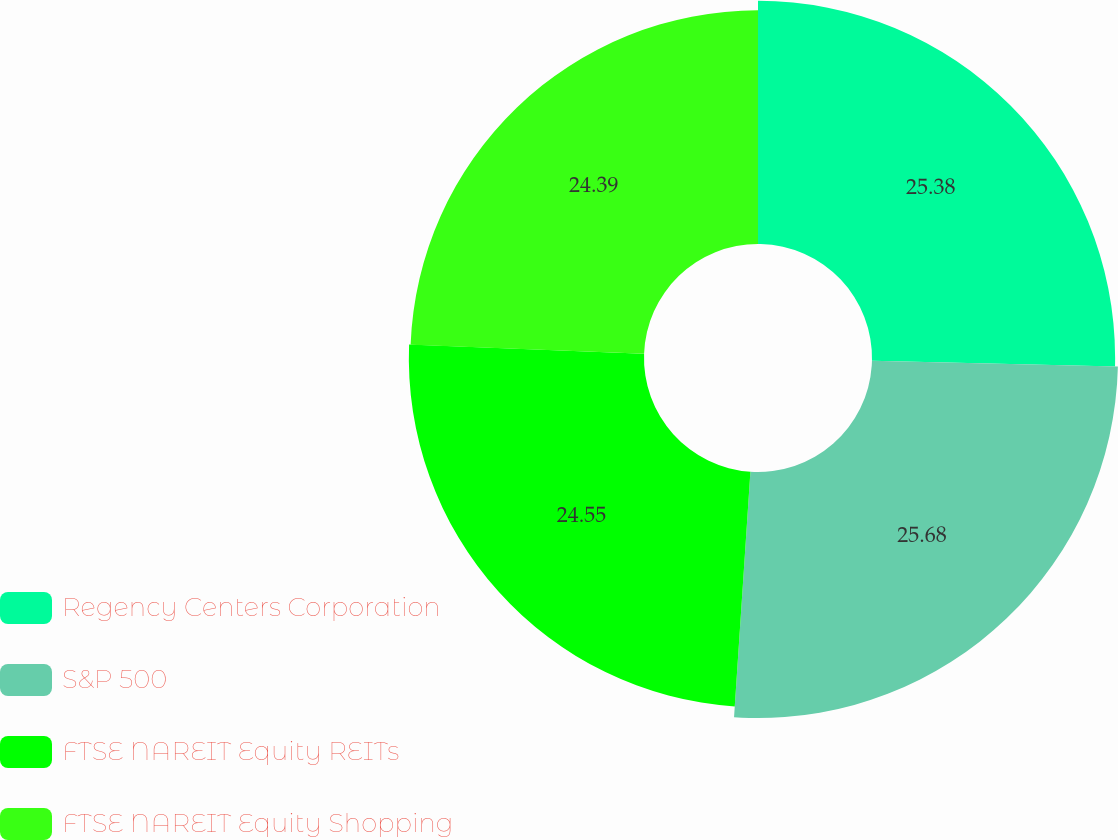Convert chart to OTSL. <chart><loc_0><loc_0><loc_500><loc_500><pie_chart><fcel>Regency Centers Corporation<fcel>S&P 500<fcel>FTSE NAREIT Equity REITs<fcel>FTSE NAREIT Equity Shopping<nl><fcel>25.38%<fcel>25.68%<fcel>24.55%<fcel>24.39%<nl></chart> 